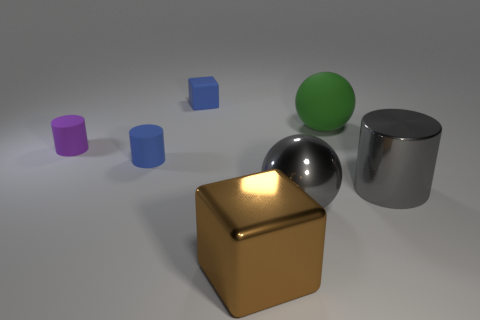How many rubber things are behind the big green sphere that is behind the big cylinder? There is one rubber item located behind the large green sphere, which is situated behind the big metallic cylinder. The rubber item appears to be a purple cylindrical shape, adding a splash of color to the composition. 